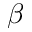Convert formula to latex. <formula><loc_0><loc_0><loc_500><loc_500>\beta</formula> 